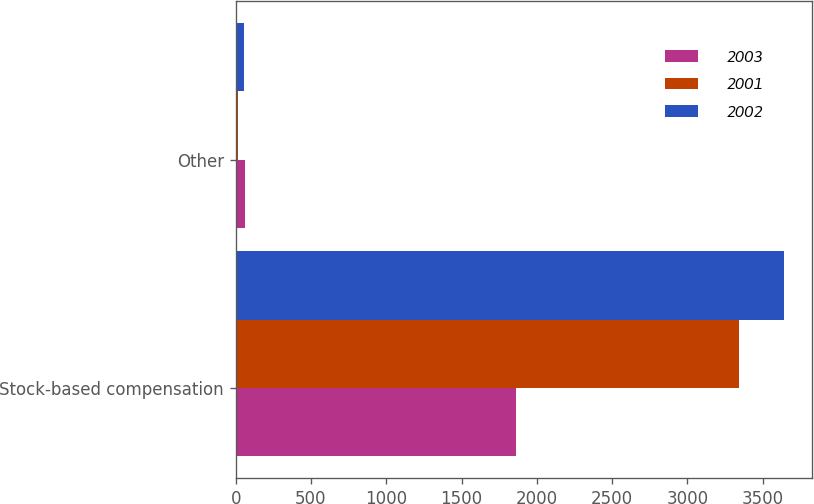Convert chart. <chart><loc_0><loc_0><loc_500><loc_500><stacked_bar_chart><ecel><fcel>Stock-based compensation<fcel>Other<nl><fcel>2003<fcel>1864<fcel>64<nl><fcel>2001<fcel>3343<fcel>15<nl><fcel>2002<fcel>3644<fcel>56<nl></chart> 